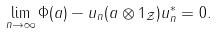<formula> <loc_0><loc_0><loc_500><loc_500>\lim _ { n \to \infty } \| \Phi ( a ) - u _ { n } ( a \otimes 1 _ { \mathcal { Z } } ) u _ { n } ^ { * } \| = 0 .</formula> 